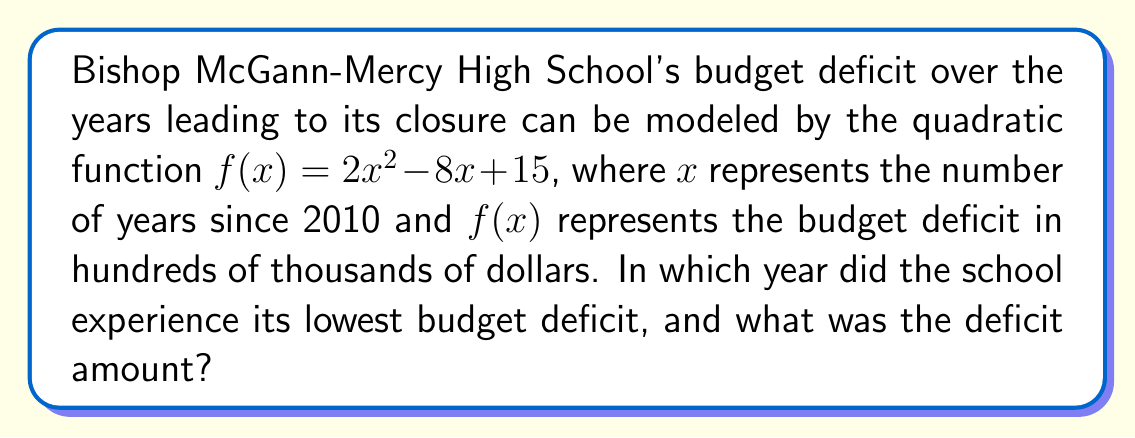Provide a solution to this math problem. To solve this problem, we need to follow these steps:

1) The quadratic function given is $f(x) = 2x^2 - 8x + 15$

2) To find the year with the lowest deficit, we need to find the minimum point of this parabola. The x-coordinate of the vertex represents the year, and the y-coordinate represents the lowest deficit.

3) For a quadratic function in the form $f(x) = ax^2 + bx + c$, the x-coordinate of the vertex is given by $x = -\frac{b}{2a}$

4) In this case, $a = 2$ and $b = -8$. So:

   $x = -\frac{-8}{2(2)} = \frac{8}{4} = 2$

5) This means the lowest point occurred 2 years after 2010, which is 2012.

6) To find the deficit amount, we need to calculate $f(2)$:

   $f(2) = 2(2)^2 - 8(2) + 15$
         $= 2(4) - 16 + 15$
         $= 8 - 16 + 15$
         $= 7$

7) Remember that $f(x)$ represents the deficit in hundreds of thousands of dollars. So, 7 here means $700,000.
Answer: The school experienced its lowest budget deficit in 2012, and the deficit amount was $700,000. 